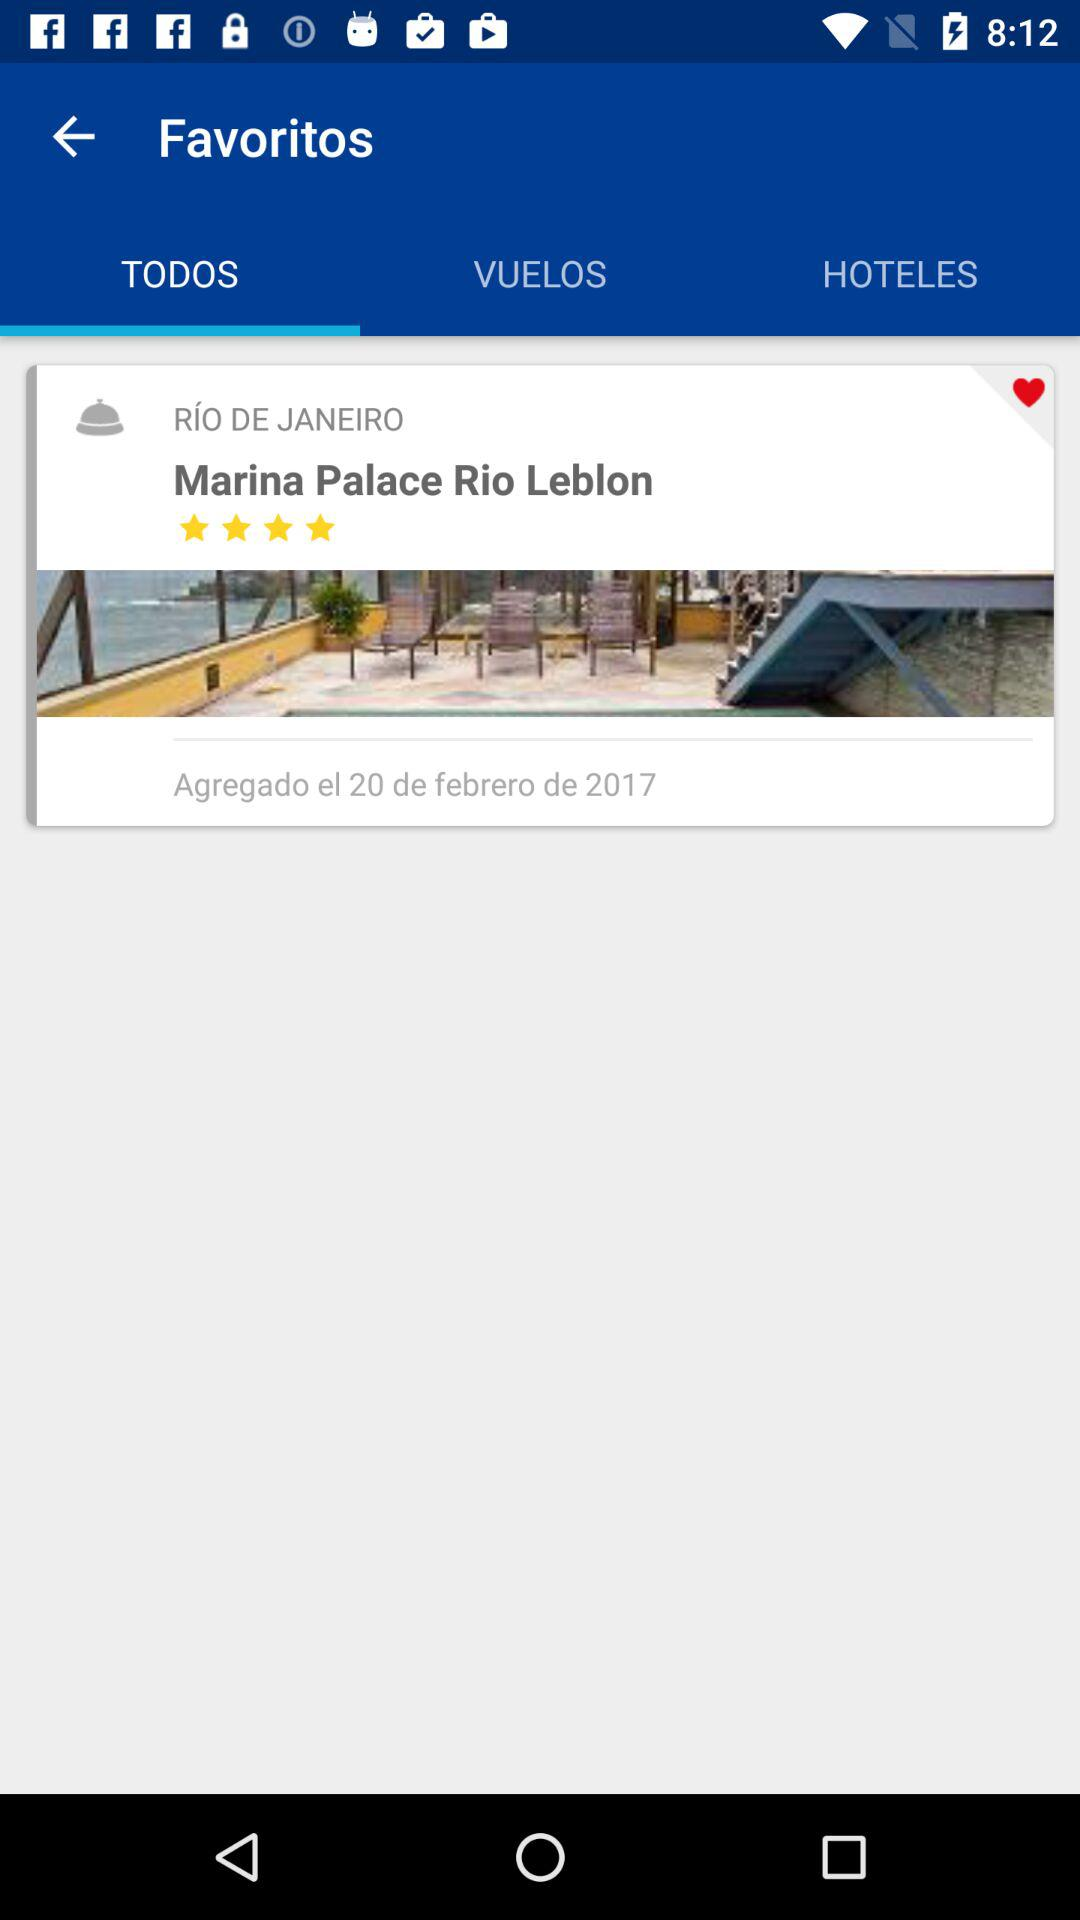What is the rating? The rating is 4 stars. 